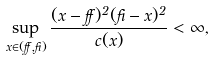Convert formula to latex. <formula><loc_0><loc_0><loc_500><loc_500>\sup _ { x \in ( \alpha , \beta ) } \frac { ( x - \alpha ) ^ { 2 } ( \beta - x ) ^ { 2 } } { c ( x ) } < \infty ,</formula> 